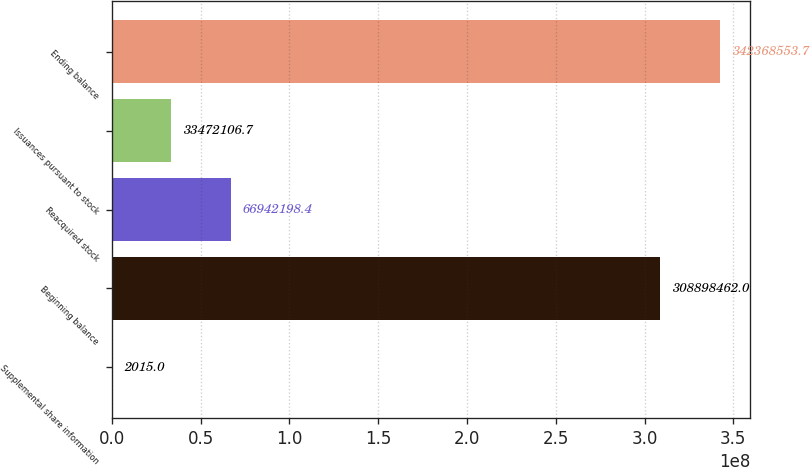<chart> <loc_0><loc_0><loc_500><loc_500><bar_chart><fcel>Supplemental share information<fcel>Beginning balance<fcel>Reacquired stock<fcel>Issuances pursuant to stock<fcel>Ending balance<nl><fcel>2015<fcel>3.08898e+08<fcel>6.69422e+07<fcel>3.34721e+07<fcel>3.42369e+08<nl></chart> 